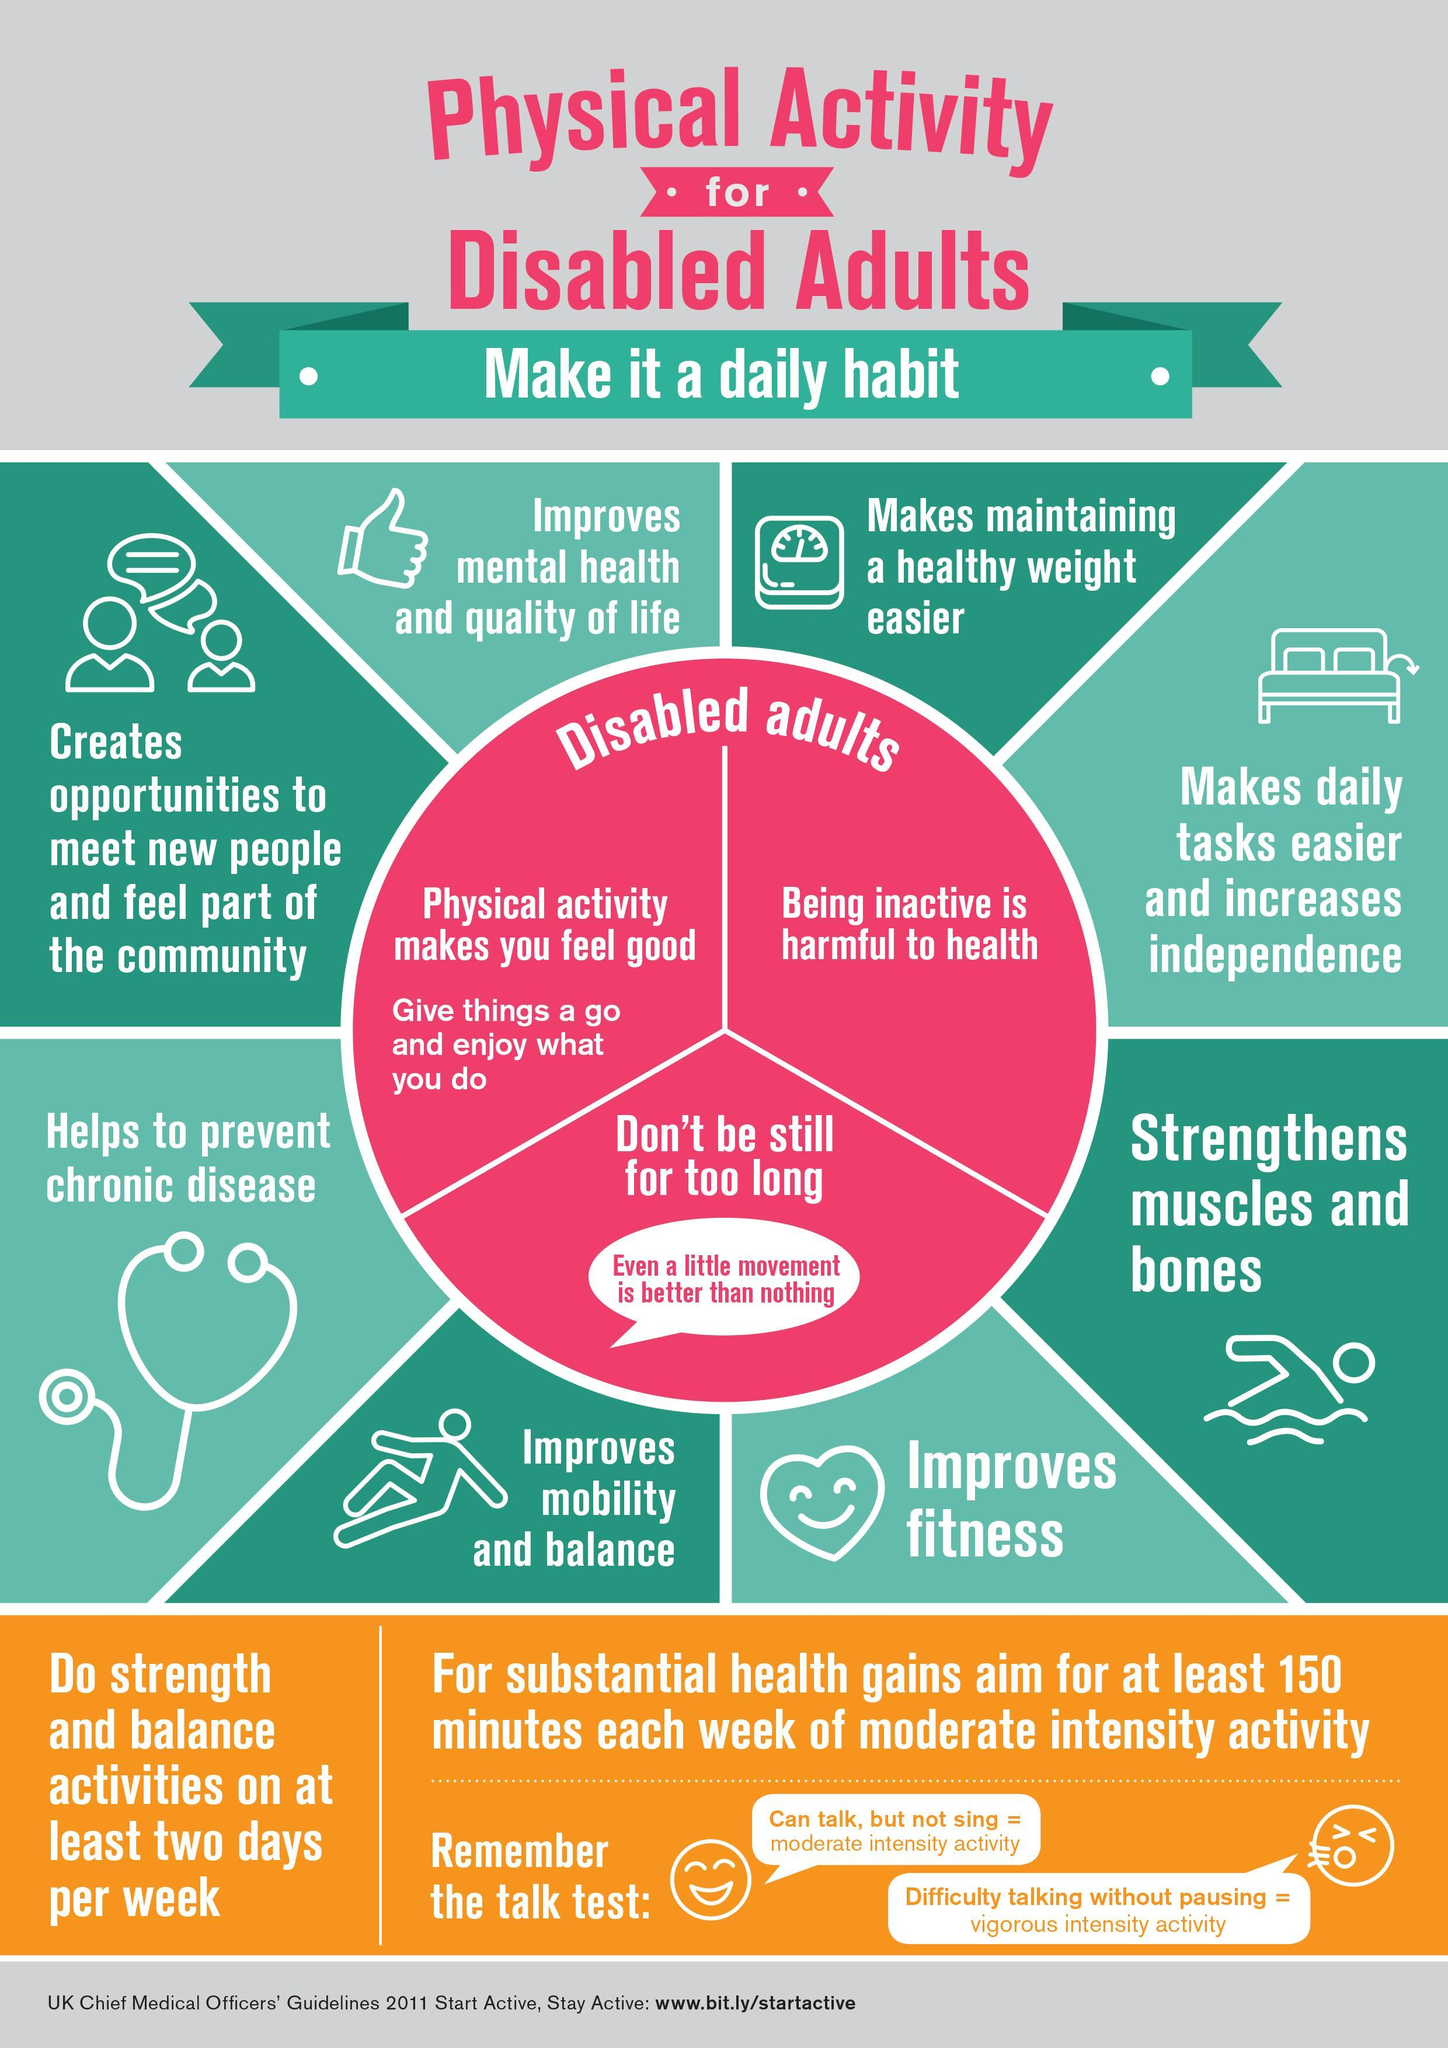Moderate intensity activity is recommended for how many minutes per week?
Answer the question with a short phrase. 150 What is harmful to health? being inactive What type of activities are recommended for two days a week? strength and balance activities What makes you feel good? physical activity What improves mental health and quality of life? Physical activity 